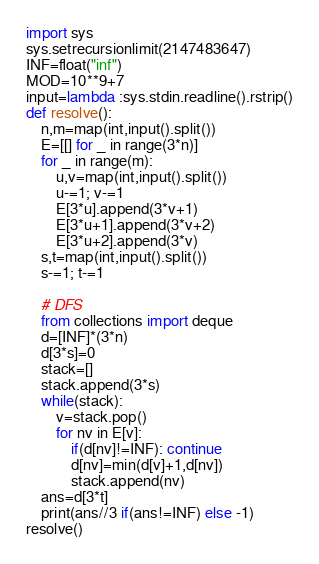<code> <loc_0><loc_0><loc_500><loc_500><_Python_>import sys
sys.setrecursionlimit(2147483647)
INF=float("inf")
MOD=10**9+7
input=lambda :sys.stdin.readline().rstrip()
def resolve():
    n,m=map(int,input().split())
    E=[[] for _ in range(3*n)]
    for _ in range(m):
        u,v=map(int,input().split())
        u-=1; v-=1
        E[3*u].append(3*v+1)
        E[3*u+1].append(3*v+2)
        E[3*u+2].append(3*v)
    s,t=map(int,input().split())
    s-=1; t-=1

    # DFS
    from collections import deque
    d=[INF]*(3*n)
    d[3*s]=0
    stack=[]
    stack.append(3*s)
    while(stack):
        v=stack.pop()
        for nv in E[v]:
            if(d[nv]!=INF): continue
            d[nv]=min(d[v]+1,d[nv])
            stack.append(nv)
    ans=d[3*t]
    print(ans//3 if(ans!=INF) else -1)
resolve()</code> 